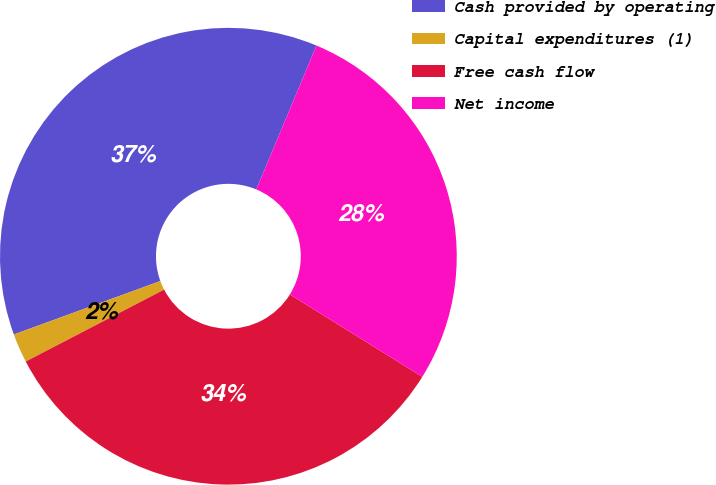Convert chart to OTSL. <chart><loc_0><loc_0><loc_500><loc_500><pie_chart><fcel>Cash provided by operating<fcel>Capital expenditures (1)<fcel>Free cash flow<fcel>Net income<nl><fcel>36.87%<fcel>2.06%<fcel>33.52%<fcel>27.55%<nl></chart> 